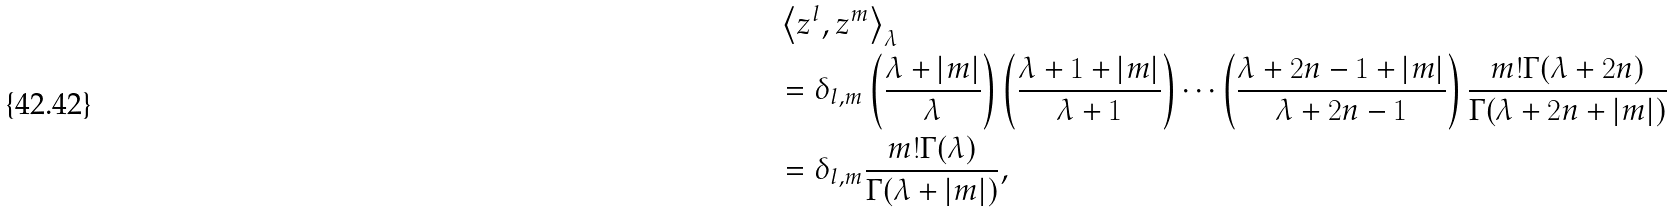<formula> <loc_0><loc_0><loc_500><loc_500>& \left \langle z ^ { l } , z ^ { m } \right \rangle _ { \lambda } \\ & = \delta _ { l , m } \left ( \frac { \lambda + | m | } { \lambda } \right ) \left ( \frac { \lambda + 1 + | m | } { \lambda + 1 } \right ) \cdots \left ( \frac { \lambda + 2 n - 1 + | m | } { \lambda + 2 n - 1 } \right ) \frac { m ! \Gamma ( \lambda + 2 n ) } { \Gamma ( \lambda + 2 n + | m | ) } \\ & = \delta _ { l , m } \frac { m ! \Gamma ( \lambda ) } { \Gamma ( \lambda + | m | ) } ,</formula> 